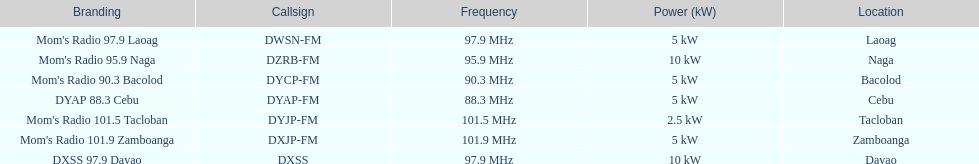What are the total number of radio stations on this list? 7. 